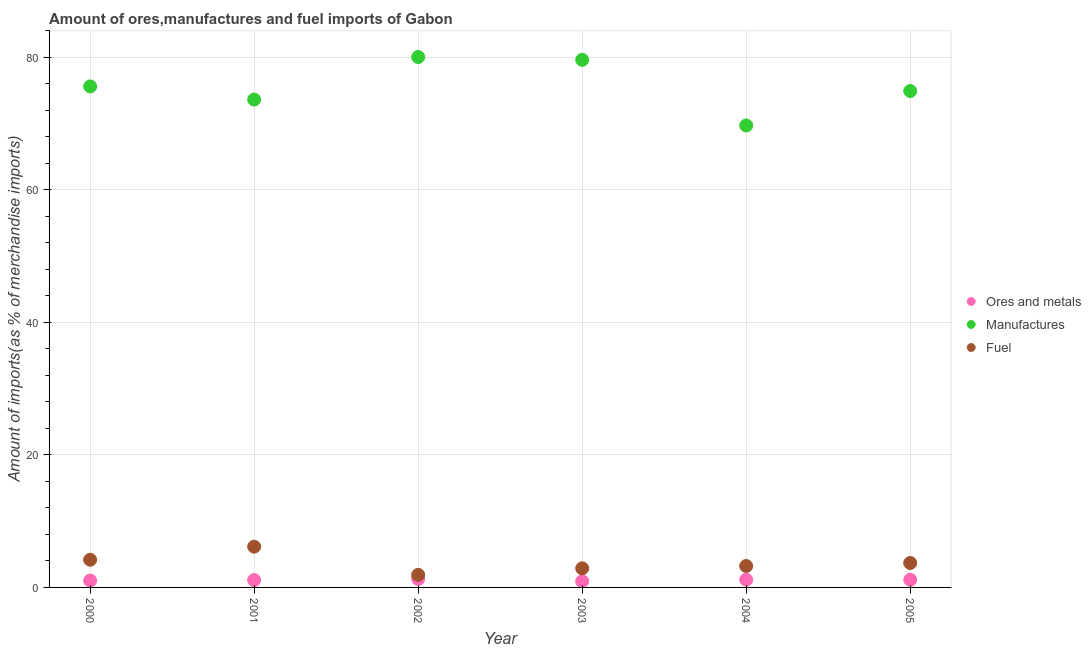How many different coloured dotlines are there?
Provide a short and direct response. 3. What is the percentage of ores and metals imports in 2003?
Keep it short and to the point. 0.93. Across all years, what is the maximum percentage of fuel imports?
Offer a very short reply. 6.15. Across all years, what is the minimum percentage of fuel imports?
Make the answer very short. 1.9. In which year was the percentage of ores and metals imports maximum?
Ensure brevity in your answer.  2002. In which year was the percentage of fuel imports minimum?
Provide a succinct answer. 2002. What is the total percentage of fuel imports in the graph?
Keep it short and to the point. 22.04. What is the difference between the percentage of fuel imports in 2000 and that in 2002?
Make the answer very short. 2.28. What is the difference between the percentage of manufactures imports in 2002 and the percentage of ores and metals imports in 2005?
Keep it short and to the point. 78.9. What is the average percentage of ores and metals imports per year?
Ensure brevity in your answer.  1.11. In the year 2000, what is the difference between the percentage of manufactures imports and percentage of fuel imports?
Keep it short and to the point. 71.45. What is the ratio of the percentage of ores and metals imports in 2000 to that in 2001?
Provide a short and direct response. 0.93. Is the percentage of ores and metals imports in 2003 less than that in 2004?
Provide a succinct answer. Yes. Is the difference between the percentage of ores and metals imports in 2002 and 2005 greater than the difference between the percentage of manufactures imports in 2002 and 2005?
Your answer should be compact. No. What is the difference between the highest and the second highest percentage of manufactures imports?
Give a very brief answer. 0.42. What is the difference between the highest and the lowest percentage of manufactures imports?
Your answer should be compact. 10.33. Does the percentage of fuel imports monotonically increase over the years?
Your response must be concise. No. Is the percentage of manufactures imports strictly greater than the percentage of ores and metals imports over the years?
Your response must be concise. Yes. How many dotlines are there?
Offer a terse response. 3. How many years are there in the graph?
Provide a short and direct response. 6. Does the graph contain grids?
Give a very brief answer. Yes. Where does the legend appear in the graph?
Your answer should be compact. Center right. How many legend labels are there?
Your answer should be compact. 3. How are the legend labels stacked?
Provide a succinct answer. Vertical. What is the title of the graph?
Offer a very short reply. Amount of ores,manufactures and fuel imports of Gabon. What is the label or title of the Y-axis?
Your answer should be very brief. Amount of imports(as % of merchandise imports). What is the Amount of imports(as % of merchandise imports) of Ores and metals in 2000?
Offer a terse response. 1.04. What is the Amount of imports(as % of merchandise imports) of Manufactures in 2000?
Offer a terse response. 75.62. What is the Amount of imports(as % of merchandise imports) of Fuel in 2000?
Provide a short and direct response. 4.18. What is the Amount of imports(as % of merchandise imports) in Ores and metals in 2001?
Provide a short and direct response. 1.11. What is the Amount of imports(as % of merchandise imports) in Manufactures in 2001?
Keep it short and to the point. 73.64. What is the Amount of imports(as % of merchandise imports) in Fuel in 2001?
Ensure brevity in your answer.  6.15. What is the Amount of imports(as % of merchandise imports) in Ores and metals in 2002?
Offer a very short reply. 1.28. What is the Amount of imports(as % of merchandise imports) in Manufactures in 2002?
Offer a terse response. 80.06. What is the Amount of imports(as % of merchandise imports) of Fuel in 2002?
Ensure brevity in your answer.  1.9. What is the Amount of imports(as % of merchandise imports) of Ores and metals in 2003?
Keep it short and to the point. 0.93. What is the Amount of imports(as % of merchandise imports) in Manufactures in 2003?
Your answer should be compact. 79.64. What is the Amount of imports(as % of merchandise imports) in Fuel in 2003?
Your answer should be compact. 2.88. What is the Amount of imports(as % of merchandise imports) in Ores and metals in 2004?
Provide a short and direct response. 1.17. What is the Amount of imports(as % of merchandise imports) of Manufactures in 2004?
Keep it short and to the point. 69.73. What is the Amount of imports(as % of merchandise imports) of Fuel in 2004?
Offer a very short reply. 3.23. What is the Amount of imports(as % of merchandise imports) in Ores and metals in 2005?
Your response must be concise. 1.16. What is the Amount of imports(as % of merchandise imports) in Manufactures in 2005?
Offer a very short reply. 74.93. What is the Amount of imports(as % of merchandise imports) in Fuel in 2005?
Your response must be concise. 3.69. Across all years, what is the maximum Amount of imports(as % of merchandise imports) in Ores and metals?
Give a very brief answer. 1.28. Across all years, what is the maximum Amount of imports(as % of merchandise imports) in Manufactures?
Your response must be concise. 80.06. Across all years, what is the maximum Amount of imports(as % of merchandise imports) in Fuel?
Your response must be concise. 6.15. Across all years, what is the minimum Amount of imports(as % of merchandise imports) of Ores and metals?
Give a very brief answer. 0.93. Across all years, what is the minimum Amount of imports(as % of merchandise imports) of Manufactures?
Give a very brief answer. 69.73. Across all years, what is the minimum Amount of imports(as % of merchandise imports) in Fuel?
Provide a short and direct response. 1.9. What is the total Amount of imports(as % of merchandise imports) in Ores and metals in the graph?
Give a very brief answer. 6.68. What is the total Amount of imports(as % of merchandise imports) in Manufactures in the graph?
Provide a short and direct response. 453.63. What is the total Amount of imports(as % of merchandise imports) of Fuel in the graph?
Make the answer very short. 22.04. What is the difference between the Amount of imports(as % of merchandise imports) of Ores and metals in 2000 and that in 2001?
Your answer should be compact. -0.07. What is the difference between the Amount of imports(as % of merchandise imports) of Manufactures in 2000 and that in 2001?
Offer a very short reply. 1.98. What is the difference between the Amount of imports(as % of merchandise imports) of Fuel in 2000 and that in 2001?
Offer a very short reply. -1.97. What is the difference between the Amount of imports(as % of merchandise imports) of Ores and metals in 2000 and that in 2002?
Provide a short and direct response. -0.24. What is the difference between the Amount of imports(as % of merchandise imports) in Manufactures in 2000 and that in 2002?
Your response must be concise. -4.44. What is the difference between the Amount of imports(as % of merchandise imports) in Fuel in 2000 and that in 2002?
Your answer should be very brief. 2.28. What is the difference between the Amount of imports(as % of merchandise imports) of Ores and metals in 2000 and that in 2003?
Your response must be concise. 0.11. What is the difference between the Amount of imports(as % of merchandise imports) of Manufactures in 2000 and that in 2003?
Your answer should be compact. -4.02. What is the difference between the Amount of imports(as % of merchandise imports) in Fuel in 2000 and that in 2003?
Ensure brevity in your answer.  1.29. What is the difference between the Amount of imports(as % of merchandise imports) of Ores and metals in 2000 and that in 2004?
Your answer should be very brief. -0.13. What is the difference between the Amount of imports(as % of merchandise imports) in Manufactures in 2000 and that in 2004?
Provide a short and direct response. 5.89. What is the difference between the Amount of imports(as % of merchandise imports) of Fuel in 2000 and that in 2004?
Give a very brief answer. 0.94. What is the difference between the Amount of imports(as % of merchandise imports) of Ores and metals in 2000 and that in 2005?
Your answer should be very brief. -0.12. What is the difference between the Amount of imports(as % of merchandise imports) in Manufactures in 2000 and that in 2005?
Offer a terse response. 0.7. What is the difference between the Amount of imports(as % of merchandise imports) of Fuel in 2000 and that in 2005?
Your answer should be very brief. 0.49. What is the difference between the Amount of imports(as % of merchandise imports) in Ores and metals in 2001 and that in 2002?
Offer a very short reply. -0.17. What is the difference between the Amount of imports(as % of merchandise imports) in Manufactures in 2001 and that in 2002?
Provide a short and direct response. -6.42. What is the difference between the Amount of imports(as % of merchandise imports) of Fuel in 2001 and that in 2002?
Offer a terse response. 4.25. What is the difference between the Amount of imports(as % of merchandise imports) in Ores and metals in 2001 and that in 2003?
Keep it short and to the point. 0.19. What is the difference between the Amount of imports(as % of merchandise imports) in Manufactures in 2001 and that in 2003?
Offer a terse response. -6. What is the difference between the Amount of imports(as % of merchandise imports) of Fuel in 2001 and that in 2003?
Give a very brief answer. 3.27. What is the difference between the Amount of imports(as % of merchandise imports) of Ores and metals in 2001 and that in 2004?
Make the answer very short. -0.06. What is the difference between the Amount of imports(as % of merchandise imports) of Manufactures in 2001 and that in 2004?
Provide a short and direct response. 3.91. What is the difference between the Amount of imports(as % of merchandise imports) in Fuel in 2001 and that in 2004?
Provide a succinct answer. 2.92. What is the difference between the Amount of imports(as % of merchandise imports) of Ores and metals in 2001 and that in 2005?
Your answer should be very brief. -0.05. What is the difference between the Amount of imports(as % of merchandise imports) in Manufactures in 2001 and that in 2005?
Keep it short and to the point. -1.29. What is the difference between the Amount of imports(as % of merchandise imports) of Fuel in 2001 and that in 2005?
Your response must be concise. 2.46. What is the difference between the Amount of imports(as % of merchandise imports) of Ores and metals in 2002 and that in 2003?
Provide a short and direct response. 0.35. What is the difference between the Amount of imports(as % of merchandise imports) in Manufactures in 2002 and that in 2003?
Offer a terse response. 0.42. What is the difference between the Amount of imports(as % of merchandise imports) of Fuel in 2002 and that in 2003?
Your response must be concise. -0.98. What is the difference between the Amount of imports(as % of merchandise imports) in Ores and metals in 2002 and that in 2004?
Your answer should be very brief. 0.11. What is the difference between the Amount of imports(as % of merchandise imports) of Manufactures in 2002 and that in 2004?
Your response must be concise. 10.33. What is the difference between the Amount of imports(as % of merchandise imports) of Fuel in 2002 and that in 2004?
Offer a very short reply. -1.33. What is the difference between the Amount of imports(as % of merchandise imports) in Ores and metals in 2002 and that in 2005?
Offer a very short reply. 0.12. What is the difference between the Amount of imports(as % of merchandise imports) in Manufactures in 2002 and that in 2005?
Offer a terse response. 5.13. What is the difference between the Amount of imports(as % of merchandise imports) of Fuel in 2002 and that in 2005?
Give a very brief answer. -1.79. What is the difference between the Amount of imports(as % of merchandise imports) in Ores and metals in 2003 and that in 2004?
Your response must be concise. -0.24. What is the difference between the Amount of imports(as % of merchandise imports) in Manufactures in 2003 and that in 2004?
Provide a short and direct response. 9.91. What is the difference between the Amount of imports(as % of merchandise imports) in Fuel in 2003 and that in 2004?
Ensure brevity in your answer.  -0.35. What is the difference between the Amount of imports(as % of merchandise imports) in Ores and metals in 2003 and that in 2005?
Offer a terse response. -0.23. What is the difference between the Amount of imports(as % of merchandise imports) of Manufactures in 2003 and that in 2005?
Your answer should be very brief. 4.71. What is the difference between the Amount of imports(as % of merchandise imports) of Fuel in 2003 and that in 2005?
Ensure brevity in your answer.  -0.81. What is the difference between the Amount of imports(as % of merchandise imports) in Ores and metals in 2004 and that in 2005?
Give a very brief answer. 0.01. What is the difference between the Amount of imports(as % of merchandise imports) of Manufactures in 2004 and that in 2005?
Keep it short and to the point. -5.2. What is the difference between the Amount of imports(as % of merchandise imports) of Fuel in 2004 and that in 2005?
Your response must be concise. -0.46. What is the difference between the Amount of imports(as % of merchandise imports) in Ores and metals in 2000 and the Amount of imports(as % of merchandise imports) in Manufactures in 2001?
Provide a short and direct response. -72.61. What is the difference between the Amount of imports(as % of merchandise imports) in Ores and metals in 2000 and the Amount of imports(as % of merchandise imports) in Fuel in 2001?
Your response must be concise. -5.11. What is the difference between the Amount of imports(as % of merchandise imports) of Manufactures in 2000 and the Amount of imports(as % of merchandise imports) of Fuel in 2001?
Provide a short and direct response. 69.47. What is the difference between the Amount of imports(as % of merchandise imports) of Ores and metals in 2000 and the Amount of imports(as % of merchandise imports) of Manufactures in 2002?
Give a very brief answer. -79.02. What is the difference between the Amount of imports(as % of merchandise imports) in Ores and metals in 2000 and the Amount of imports(as % of merchandise imports) in Fuel in 2002?
Provide a short and direct response. -0.87. What is the difference between the Amount of imports(as % of merchandise imports) in Manufactures in 2000 and the Amount of imports(as % of merchandise imports) in Fuel in 2002?
Make the answer very short. 73.72. What is the difference between the Amount of imports(as % of merchandise imports) in Ores and metals in 2000 and the Amount of imports(as % of merchandise imports) in Manufactures in 2003?
Offer a terse response. -78.6. What is the difference between the Amount of imports(as % of merchandise imports) in Ores and metals in 2000 and the Amount of imports(as % of merchandise imports) in Fuel in 2003?
Your answer should be very brief. -1.85. What is the difference between the Amount of imports(as % of merchandise imports) of Manufactures in 2000 and the Amount of imports(as % of merchandise imports) of Fuel in 2003?
Offer a very short reply. 72.74. What is the difference between the Amount of imports(as % of merchandise imports) of Ores and metals in 2000 and the Amount of imports(as % of merchandise imports) of Manufactures in 2004?
Your answer should be compact. -68.69. What is the difference between the Amount of imports(as % of merchandise imports) in Ores and metals in 2000 and the Amount of imports(as % of merchandise imports) in Fuel in 2004?
Your answer should be very brief. -2.2. What is the difference between the Amount of imports(as % of merchandise imports) of Manufactures in 2000 and the Amount of imports(as % of merchandise imports) of Fuel in 2004?
Offer a very short reply. 72.39. What is the difference between the Amount of imports(as % of merchandise imports) of Ores and metals in 2000 and the Amount of imports(as % of merchandise imports) of Manufactures in 2005?
Keep it short and to the point. -73.89. What is the difference between the Amount of imports(as % of merchandise imports) in Ores and metals in 2000 and the Amount of imports(as % of merchandise imports) in Fuel in 2005?
Give a very brief answer. -2.65. What is the difference between the Amount of imports(as % of merchandise imports) in Manufactures in 2000 and the Amount of imports(as % of merchandise imports) in Fuel in 2005?
Your response must be concise. 71.93. What is the difference between the Amount of imports(as % of merchandise imports) in Ores and metals in 2001 and the Amount of imports(as % of merchandise imports) in Manufactures in 2002?
Ensure brevity in your answer.  -78.95. What is the difference between the Amount of imports(as % of merchandise imports) of Ores and metals in 2001 and the Amount of imports(as % of merchandise imports) of Fuel in 2002?
Your response must be concise. -0.79. What is the difference between the Amount of imports(as % of merchandise imports) of Manufactures in 2001 and the Amount of imports(as % of merchandise imports) of Fuel in 2002?
Your answer should be very brief. 71.74. What is the difference between the Amount of imports(as % of merchandise imports) in Ores and metals in 2001 and the Amount of imports(as % of merchandise imports) in Manufactures in 2003?
Keep it short and to the point. -78.53. What is the difference between the Amount of imports(as % of merchandise imports) in Ores and metals in 2001 and the Amount of imports(as % of merchandise imports) in Fuel in 2003?
Provide a short and direct response. -1.77. What is the difference between the Amount of imports(as % of merchandise imports) in Manufactures in 2001 and the Amount of imports(as % of merchandise imports) in Fuel in 2003?
Offer a very short reply. 70.76. What is the difference between the Amount of imports(as % of merchandise imports) of Ores and metals in 2001 and the Amount of imports(as % of merchandise imports) of Manufactures in 2004?
Provide a succinct answer. -68.62. What is the difference between the Amount of imports(as % of merchandise imports) of Ores and metals in 2001 and the Amount of imports(as % of merchandise imports) of Fuel in 2004?
Make the answer very short. -2.12. What is the difference between the Amount of imports(as % of merchandise imports) in Manufactures in 2001 and the Amount of imports(as % of merchandise imports) in Fuel in 2004?
Offer a very short reply. 70.41. What is the difference between the Amount of imports(as % of merchandise imports) in Ores and metals in 2001 and the Amount of imports(as % of merchandise imports) in Manufactures in 2005?
Give a very brief answer. -73.82. What is the difference between the Amount of imports(as % of merchandise imports) of Ores and metals in 2001 and the Amount of imports(as % of merchandise imports) of Fuel in 2005?
Ensure brevity in your answer.  -2.58. What is the difference between the Amount of imports(as % of merchandise imports) of Manufactures in 2001 and the Amount of imports(as % of merchandise imports) of Fuel in 2005?
Ensure brevity in your answer.  69.95. What is the difference between the Amount of imports(as % of merchandise imports) in Ores and metals in 2002 and the Amount of imports(as % of merchandise imports) in Manufactures in 2003?
Offer a very short reply. -78.36. What is the difference between the Amount of imports(as % of merchandise imports) of Ores and metals in 2002 and the Amount of imports(as % of merchandise imports) of Fuel in 2003?
Your answer should be very brief. -1.61. What is the difference between the Amount of imports(as % of merchandise imports) in Manufactures in 2002 and the Amount of imports(as % of merchandise imports) in Fuel in 2003?
Your response must be concise. 77.18. What is the difference between the Amount of imports(as % of merchandise imports) in Ores and metals in 2002 and the Amount of imports(as % of merchandise imports) in Manufactures in 2004?
Ensure brevity in your answer.  -68.45. What is the difference between the Amount of imports(as % of merchandise imports) in Ores and metals in 2002 and the Amount of imports(as % of merchandise imports) in Fuel in 2004?
Provide a short and direct response. -1.96. What is the difference between the Amount of imports(as % of merchandise imports) of Manufactures in 2002 and the Amount of imports(as % of merchandise imports) of Fuel in 2004?
Your answer should be compact. 76.83. What is the difference between the Amount of imports(as % of merchandise imports) of Ores and metals in 2002 and the Amount of imports(as % of merchandise imports) of Manufactures in 2005?
Your answer should be very brief. -73.65. What is the difference between the Amount of imports(as % of merchandise imports) in Ores and metals in 2002 and the Amount of imports(as % of merchandise imports) in Fuel in 2005?
Your answer should be very brief. -2.41. What is the difference between the Amount of imports(as % of merchandise imports) in Manufactures in 2002 and the Amount of imports(as % of merchandise imports) in Fuel in 2005?
Ensure brevity in your answer.  76.37. What is the difference between the Amount of imports(as % of merchandise imports) in Ores and metals in 2003 and the Amount of imports(as % of merchandise imports) in Manufactures in 2004?
Keep it short and to the point. -68.8. What is the difference between the Amount of imports(as % of merchandise imports) of Ores and metals in 2003 and the Amount of imports(as % of merchandise imports) of Fuel in 2004?
Give a very brief answer. -2.31. What is the difference between the Amount of imports(as % of merchandise imports) of Manufactures in 2003 and the Amount of imports(as % of merchandise imports) of Fuel in 2004?
Make the answer very short. 76.41. What is the difference between the Amount of imports(as % of merchandise imports) of Ores and metals in 2003 and the Amount of imports(as % of merchandise imports) of Manufactures in 2005?
Offer a very short reply. -74. What is the difference between the Amount of imports(as % of merchandise imports) in Ores and metals in 2003 and the Amount of imports(as % of merchandise imports) in Fuel in 2005?
Your response must be concise. -2.77. What is the difference between the Amount of imports(as % of merchandise imports) of Manufactures in 2003 and the Amount of imports(as % of merchandise imports) of Fuel in 2005?
Keep it short and to the point. 75.95. What is the difference between the Amount of imports(as % of merchandise imports) of Ores and metals in 2004 and the Amount of imports(as % of merchandise imports) of Manufactures in 2005?
Offer a terse response. -73.76. What is the difference between the Amount of imports(as % of merchandise imports) in Ores and metals in 2004 and the Amount of imports(as % of merchandise imports) in Fuel in 2005?
Your answer should be compact. -2.52. What is the difference between the Amount of imports(as % of merchandise imports) of Manufactures in 2004 and the Amount of imports(as % of merchandise imports) of Fuel in 2005?
Provide a short and direct response. 66.04. What is the average Amount of imports(as % of merchandise imports) of Ores and metals per year?
Give a very brief answer. 1.11. What is the average Amount of imports(as % of merchandise imports) of Manufactures per year?
Ensure brevity in your answer.  75.6. What is the average Amount of imports(as % of merchandise imports) of Fuel per year?
Give a very brief answer. 3.67. In the year 2000, what is the difference between the Amount of imports(as % of merchandise imports) in Ores and metals and Amount of imports(as % of merchandise imports) in Manufactures?
Make the answer very short. -74.59. In the year 2000, what is the difference between the Amount of imports(as % of merchandise imports) of Ores and metals and Amount of imports(as % of merchandise imports) of Fuel?
Provide a succinct answer. -3.14. In the year 2000, what is the difference between the Amount of imports(as % of merchandise imports) of Manufactures and Amount of imports(as % of merchandise imports) of Fuel?
Ensure brevity in your answer.  71.45. In the year 2001, what is the difference between the Amount of imports(as % of merchandise imports) in Ores and metals and Amount of imports(as % of merchandise imports) in Manufactures?
Your response must be concise. -72.53. In the year 2001, what is the difference between the Amount of imports(as % of merchandise imports) in Ores and metals and Amount of imports(as % of merchandise imports) in Fuel?
Ensure brevity in your answer.  -5.04. In the year 2001, what is the difference between the Amount of imports(as % of merchandise imports) in Manufactures and Amount of imports(as % of merchandise imports) in Fuel?
Your response must be concise. 67.49. In the year 2002, what is the difference between the Amount of imports(as % of merchandise imports) in Ores and metals and Amount of imports(as % of merchandise imports) in Manufactures?
Your answer should be compact. -78.78. In the year 2002, what is the difference between the Amount of imports(as % of merchandise imports) of Ores and metals and Amount of imports(as % of merchandise imports) of Fuel?
Your answer should be compact. -0.62. In the year 2002, what is the difference between the Amount of imports(as % of merchandise imports) in Manufactures and Amount of imports(as % of merchandise imports) in Fuel?
Make the answer very short. 78.16. In the year 2003, what is the difference between the Amount of imports(as % of merchandise imports) of Ores and metals and Amount of imports(as % of merchandise imports) of Manufactures?
Provide a short and direct response. -78.72. In the year 2003, what is the difference between the Amount of imports(as % of merchandise imports) in Ores and metals and Amount of imports(as % of merchandise imports) in Fuel?
Provide a short and direct response. -1.96. In the year 2003, what is the difference between the Amount of imports(as % of merchandise imports) in Manufactures and Amount of imports(as % of merchandise imports) in Fuel?
Make the answer very short. 76.76. In the year 2004, what is the difference between the Amount of imports(as % of merchandise imports) in Ores and metals and Amount of imports(as % of merchandise imports) in Manufactures?
Your response must be concise. -68.56. In the year 2004, what is the difference between the Amount of imports(as % of merchandise imports) in Ores and metals and Amount of imports(as % of merchandise imports) in Fuel?
Your response must be concise. -2.06. In the year 2004, what is the difference between the Amount of imports(as % of merchandise imports) of Manufactures and Amount of imports(as % of merchandise imports) of Fuel?
Provide a short and direct response. 66.5. In the year 2005, what is the difference between the Amount of imports(as % of merchandise imports) of Ores and metals and Amount of imports(as % of merchandise imports) of Manufactures?
Make the answer very short. -73.77. In the year 2005, what is the difference between the Amount of imports(as % of merchandise imports) in Ores and metals and Amount of imports(as % of merchandise imports) in Fuel?
Your answer should be compact. -2.53. In the year 2005, what is the difference between the Amount of imports(as % of merchandise imports) of Manufactures and Amount of imports(as % of merchandise imports) of Fuel?
Your answer should be very brief. 71.24. What is the ratio of the Amount of imports(as % of merchandise imports) of Ores and metals in 2000 to that in 2001?
Make the answer very short. 0.93. What is the ratio of the Amount of imports(as % of merchandise imports) of Manufactures in 2000 to that in 2001?
Provide a succinct answer. 1.03. What is the ratio of the Amount of imports(as % of merchandise imports) in Fuel in 2000 to that in 2001?
Make the answer very short. 0.68. What is the ratio of the Amount of imports(as % of merchandise imports) of Ores and metals in 2000 to that in 2002?
Make the answer very short. 0.81. What is the ratio of the Amount of imports(as % of merchandise imports) of Manufactures in 2000 to that in 2002?
Keep it short and to the point. 0.94. What is the ratio of the Amount of imports(as % of merchandise imports) in Fuel in 2000 to that in 2002?
Ensure brevity in your answer.  2.2. What is the ratio of the Amount of imports(as % of merchandise imports) in Ores and metals in 2000 to that in 2003?
Offer a very short reply. 1.12. What is the ratio of the Amount of imports(as % of merchandise imports) in Manufactures in 2000 to that in 2003?
Your answer should be compact. 0.95. What is the ratio of the Amount of imports(as % of merchandise imports) of Fuel in 2000 to that in 2003?
Provide a succinct answer. 1.45. What is the ratio of the Amount of imports(as % of merchandise imports) in Ores and metals in 2000 to that in 2004?
Provide a short and direct response. 0.89. What is the ratio of the Amount of imports(as % of merchandise imports) in Manufactures in 2000 to that in 2004?
Provide a short and direct response. 1.08. What is the ratio of the Amount of imports(as % of merchandise imports) in Fuel in 2000 to that in 2004?
Your answer should be very brief. 1.29. What is the ratio of the Amount of imports(as % of merchandise imports) in Ores and metals in 2000 to that in 2005?
Your response must be concise. 0.9. What is the ratio of the Amount of imports(as % of merchandise imports) in Manufactures in 2000 to that in 2005?
Give a very brief answer. 1.01. What is the ratio of the Amount of imports(as % of merchandise imports) of Fuel in 2000 to that in 2005?
Provide a succinct answer. 1.13. What is the ratio of the Amount of imports(as % of merchandise imports) of Ores and metals in 2001 to that in 2002?
Your answer should be compact. 0.87. What is the ratio of the Amount of imports(as % of merchandise imports) of Manufactures in 2001 to that in 2002?
Provide a succinct answer. 0.92. What is the ratio of the Amount of imports(as % of merchandise imports) in Fuel in 2001 to that in 2002?
Give a very brief answer. 3.23. What is the ratio of the Amount of imports(as % of merchandise imports) in Ores and metals in 2001 to that in 2003?
Offer a terse response. 1.2. What is the ratio of the Amount of imports(as % of merchandise imports) of Manufactures in 2001 to that in 2003?
Give a very brief answer. 0.92. What is the ratio of the Amount of imports(as % of merchandise imports) in Fuel in 2001 to that in 2003?
Make the answer very short. 2.13. What is the ratio of the Amount of imports(as % of merchandise imports) in Ores and metals in 2001 to that in 2004?
Keep it short and to the point. 0.95. What is the ratio of the Amount of imports(as % of merchandise imports) in Manufactures in 2001 to that in 2004?
Your answer should be compact. 1.06. What is the ratio of the Amount of imports(as % of merchandise imports) of Fuel in 2001 to that in 2004?
Ensure brevity in your answer.  1.9. What is the ratio of the Amount of imports(as % of merchandise imports) in Ores and metals in 2001 to that in 2005?
Your answer should be very brief. 0.96. What is the ratio of the Amount of imports(as % of merchandise imports) in Manufactures in 2001 to that in 2005?
Provide a succinct answer. 0.98. What is the ratio of the Amount of imports(as % of merchandise imports) of Fuel in 2001 to that in 2005?
Make the answer very short. 1.67. What is the ratio of the Amount of imports(as % of merchandise imports) of Ores and metals in 2002 to that in 2003?
Offer a terse response. 1.38. What is the ratio of the Amount of imports(as % of merchandise imports) in Manufactures in 2002 to that in 2003?
Offer a very short reply. 1.01. What is the ratio of the Amount of imports(as % of merchandise imports) of Fuel in 2002 to that in 2003?
Your answer should be very brief. 0.66. What is the ratio of the Amount of imports(as % of merchandise imports) of Ores and metals in 2002 to that in 2004?
Offer a very short reply. 1.09. What is the ratio of the Amount of imports(as % of merchandise imports) in Manufactures in 2002 to that in 2004?
Provide a succinct answer. 1.15. What is the ratio of the Amount of imports(as % of merchandise imports) of Fuel in 2002 to that in 2004?
Your answer should be compact. 0.59. What is the ratio of the Amount of imports(as % of merchandise imports) in Ores and metals in 2002 to that in 2005?
Ensure brevity in your answer.  1.1. What is the ratio of the Amount of imports(as % of merchandise imports) in Manufactures in 2002 to that in 2005?
Make the answer very short. 1.07. What is the ratio of the Amount of imports(as % of merchandise imports) of Fuel in 2002 to that in 2005?
Offer a terse response. 0.52. What is the ratio of the Amount of imports(as % of merchandise imports) in Ores and metals in 2003 to that in 2004?
Keep it short and to the point. 0.79. What is the ratio of the Amount of imports(as % of merchandise imports) in Manufactures in 2003 to that in 2004?
Your answer should be very brief. 1.14. What is the ratio of the Amount of imports(as % of merchandise imports) in Fuel in 2003 to that in 2004?
Keep it short and to the point. 0.89. What is the ratio of the Amount of imports(as % of merchandise imports) of Ores and metals in 2003 to that in 2005?
Offer a very short reply. 0.8. What is the ratio of the Amount of imports(as % of merchandise imports) in Manufactures in 2003 to that in 2005?
Offer a very short reply. 1.06. What is the ratio of the Amount of imports(as % of merchandise imports) in Fuel in 2003 to that in 2005?
Make the answer very short. 0.78. What is the ratio of the Amount of imports(as % of merchandise imports) of Ores and metals in 2004 to that in 2005?
Give a very brief answer. 1.01. What is the ratio of the Amount of imports(as % of merchandise imports) in Manufactures in 2004 to that in 2005?
Your response must be concise. 0.93. What is the ratio of the Amount of imports(as % of merchandise imports) in Fuel in 2004 to that in 2005?
Your response must be concise. 0.88. What is the difference between the highest and the second highest Amount of imports(as % of merchandise imports) in Ores and metals?
Offer a terse response. 0.11. What is the difference between the highest and the second highest Amount of imports(as % of merchandise imports) of Manufactures?
Offer a very short reply. 0.42. What is the difference between the highest and the second highest Amount of imports(as % of merchandise imports) in Fuel?
Provide a succinct answer. 1.97. What is the difference between the highest and the lowest Amount of imports(as % of merchandise imports) in Ores and metals?
Offer a very short reply. 0.35. What is the difference between the highest and the lowest Amount of imports(as % of merchandise imports) of Manufactures?
Give a very brief answer. 10.33. What is the difference between the highest and the lowest Amount of imports(as % of merchandise imports) in Fuel?
Make the answer very short. 4.25. 